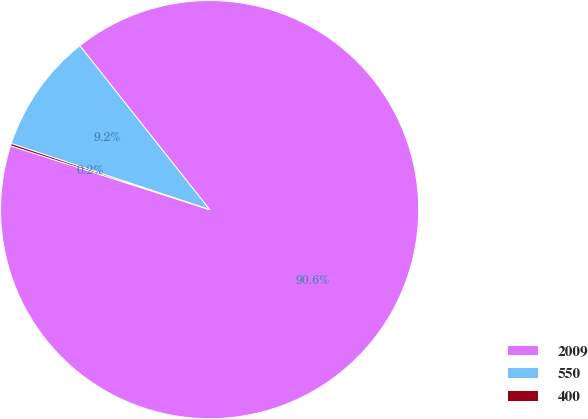Convert chart. <chart><loc_0><loc_0><loc_500><loc_500><pie_chart><fcel>2009<fcel>550<fcel>400<nl><fcel>90.6%<fcel>9.22%<fcel>0.18%<nl></chart> 